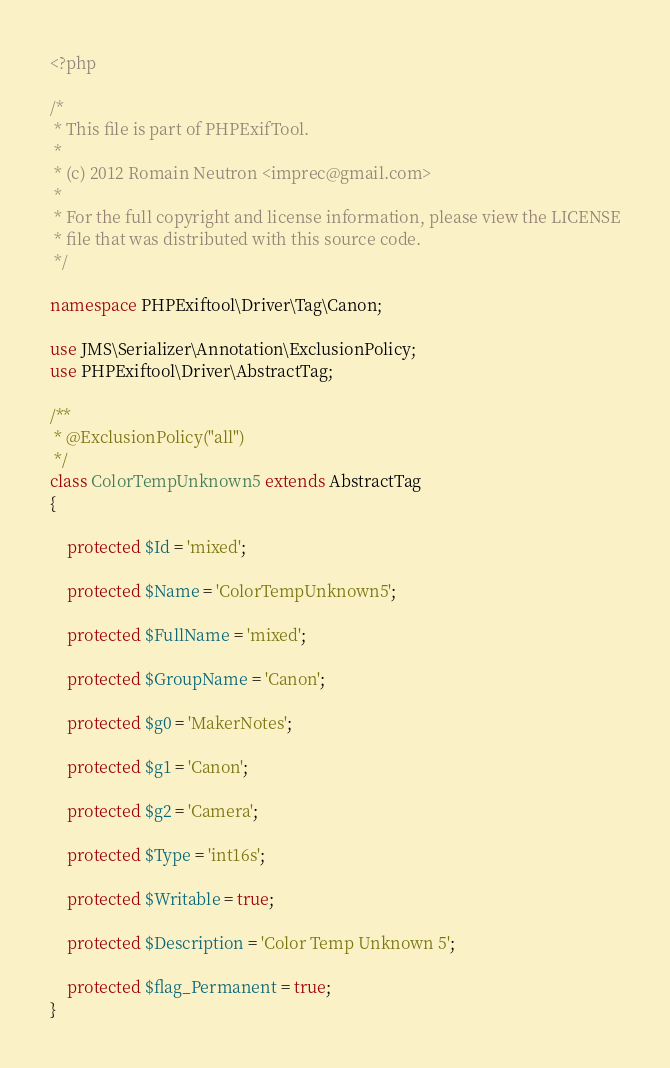Convert code to text. <code><loc_0><loc_0><loc_500><loc_500><_PHP_><?php

/*
 * This file is part of PHPExifTool.
 *
 * (c) 2012 Romain Neutron <imprec@gmail.com>
 *
 * For the full copyright and license information, please view the LICENSE
 * file that was distributed with this source code.
 */

namespace PHPExiftool\Driver\Tag\Canon;

use JMS\Serializer\Annotation\ExclusionPolicy;
use PHPExiftool\Driver\AbstractTag;

/**
 * @ExclusionPolicy("all")
 */
class ColorTempUnknown5 extends AbstractTag
{

    protected $Id = 'mixed';

    protected $Name = 'ColorTempUnknown5';

    protected $FullName = 'mixed';

    protected $GroupName = 'Canon';

    protected $g0 = 'MakerNotes';

    protected $g1 = 'Canon';

    protected $g2 = 'Camera';

    protected $Type = 'int16s';

    protected $Writable = true;

    protected $Description = 'Color Temp Unknown 5';

    protected $flag_Permanent = true;
}
</code> 